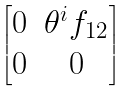Convert formula to latex. <formula><loc_0><loc_0><loc_500><loc_500>\begin{bmatrix} 0 & \theta ^ { i } f _ { 1 2 } \\ 0 & 0 \end{bmatrix}</formula> 